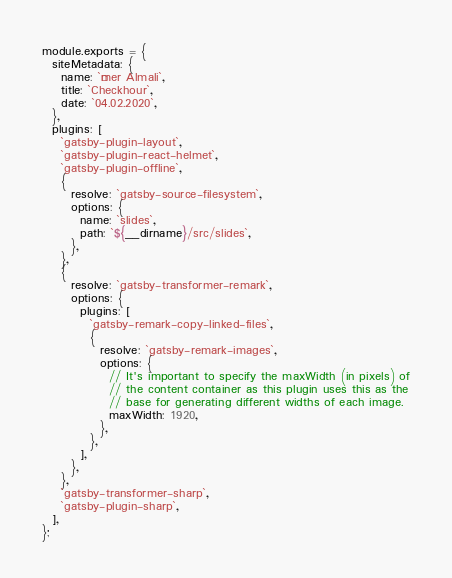Convert code to text. <code><loc_0><loc_0><loc_500><loc_500><_JavaScript_>module.exports = {
  siteMetadata: {
    name: `Ömer Almali`,
    title: `Checkhour`,
    date: `04.02.2020`,
  },
  plugins: [
    `gatsby-plugin-layout`,
    `gatsby-plugin-react-helmet`,
    `gatsby-plugin-offline`,
    {
      resolve: `gatsby-source-filesystem`,
      options: {
        name: `slides`,
        path: `${__dirname}/src/slides`,
      },
    },
    {
      resolve: `gatsby-transformer-remark`,
      options: {
        plugins: [
          `gatsby-remark-copy-linked-files`,
          {
            resolve: `gatsby-remark-images`,
            options: {
              // It's important to specify the maxWidth (in pixels) of
              // the content container as this plugin uses this as the
              // base for generating different widths of each image.
              maxWidth: 1920,
            },
          },
        ],
      },
    },
    `gatsby-transformer-sharp`,
    `gatsby-plugin-sharp`,
  ],
};
</code> 